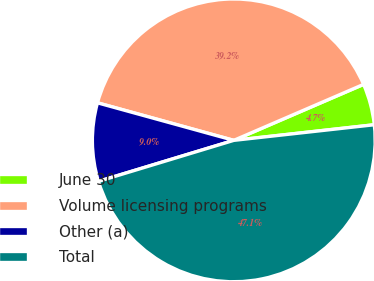Convert chart. <chart><loc_0><loc_0><loc_500><loc_500><pie_chart><fcel>June 30<fcel>Volume licensing programs<fcel>Other (a)<fcel>Total<nl><fcel>4.72%<fcel>39.24%<fcel>8.96%<fcel>47.08%<nl></chart> 